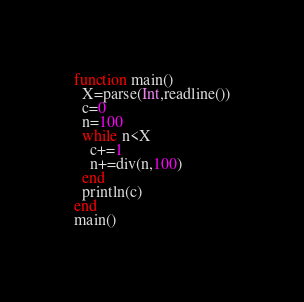Convert code to text. <code><loc_0><loc_0><loc_500><loc_500><_Julia_>function main()
  X=parse(Int,readline())
  c=0
  n=100
  while n<X
    c+=1
    n+=div(n,100)
  end
  println(c)
end
main()</code> 